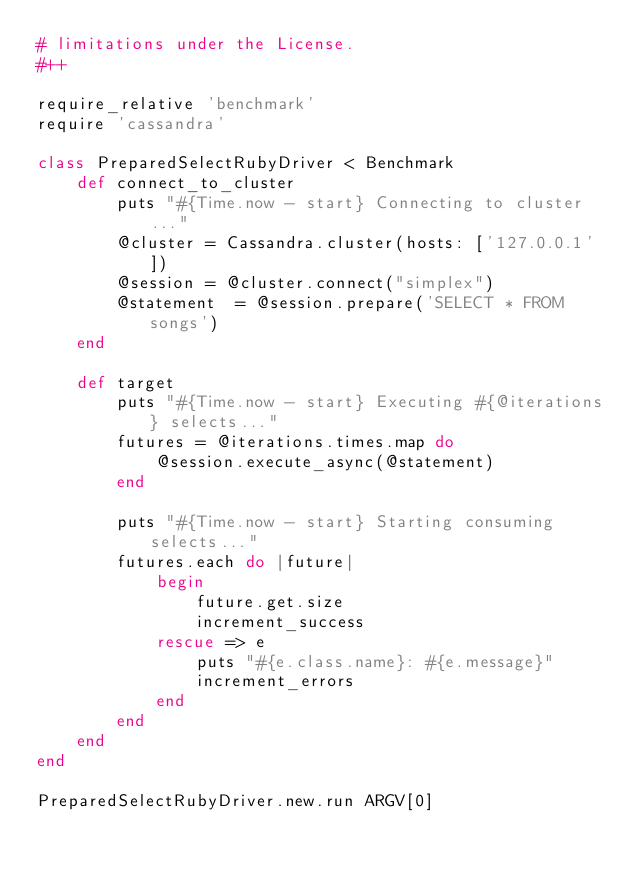Convert code to text. <code><loc_0><loc_0><loc_500><loc_500><_Ruby_># limitations under the License.
#++

require_relative 'benchmark'
require 'cassandra'

class PreparedSelectRubyDriver < Benchmark
    def connect_to_cluster
        puts "#{Time.now - start} Connecting to cluster..."
        @cluster = Cassandra.cluster(hosts: ['127.0.0.1'])
        @session = @cluster.connect("simplex")
        @statement  = @session.prepare('SELECT * FROM songs')
    end

    def target
        puts "#{Time.now - start} Executing #{@iterations} selects..."
        futures = @iterations.times.map do
            @session.execute_async(@statement)
        end

        puts "#{Time.now - start} Starting consuming selects..."
        futures.each do |future|
            begin
                future.get.size
                increment_success
            rescue => e
                puts "#{e.class.name}: #{e.message}"
                increment_errors
            end
        end
    end
end

PreparedSelectRubyDriver.new.run ARGV[0]
</code> 